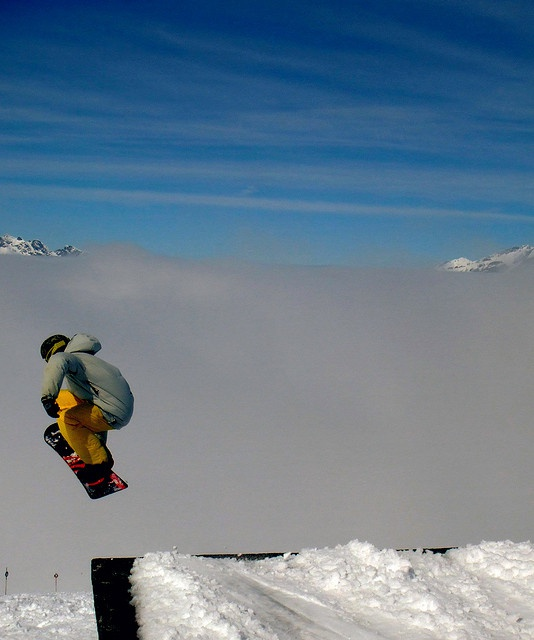Describe the objects in this image and their specific colors. I can see people in navy, black, gray, maroon, and olive tones and snowboard in navy, black, brown, maroon, and gray tones in this image. 